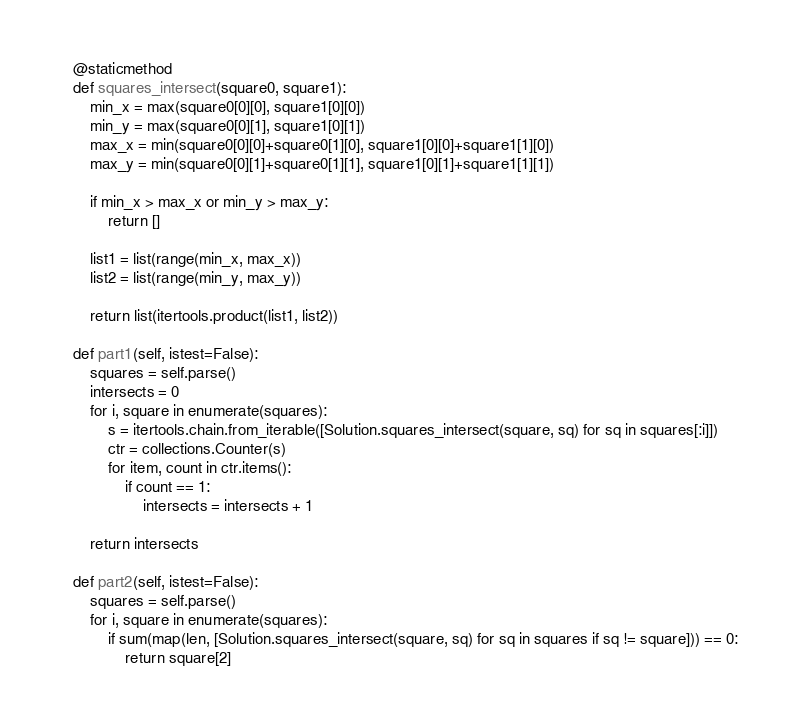<code> <loc_0><loc_0><loc_500><loc_500><_Python_>    @staticmethod
    def squares_intersect(square0, square1):
        min_x = max(square0[0][0], square1[0][0])
        min_y = max(square0[0][1], square1[0][1])
        max_x = min(square0[0][0]+square0[1][0], square1[0][0]+square1[1][0])
        max_y = min(square0[0][1]+square0[1][1], square1[0][1]+square1[1][1])

        if min_x > max_x or min_y > max_y:
            return []

        list1 = list(range(min_x, max_x))
        list2 = list(range(min_y, max_y))

        return list(itertools.product(list1, list2))

    def part1(self, istest=False):
        squares = self.parse()
        intersects = 0
        for i, square in enumerate(squares):
            s = itertools.chain.from_iterable([Solution.squares_intersect(square, sq) for sq in squares[:i]])
            ctr = collections.Counter(s)
            for item, count in ctr.items():
                if count == 1:
                    intersects = intersects + 1

        return intersects

    def part2(self, istest=False):
        squares = self.parse()
        for i, square in enumerate(squares):
            if sum(map(len, [Solution.squares_intersect(square, sq) for sq in squares if sq != square])) == 0:
                return square[2]
</code> 